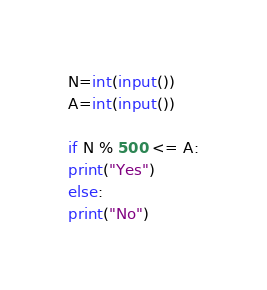<code> <loc_0><loc_0><loc_500><loc_500><_Python_>N=int(input())
A=int(input())
 
if N % 500 <= A:
print("Yes")
else:
print("No")</code> 